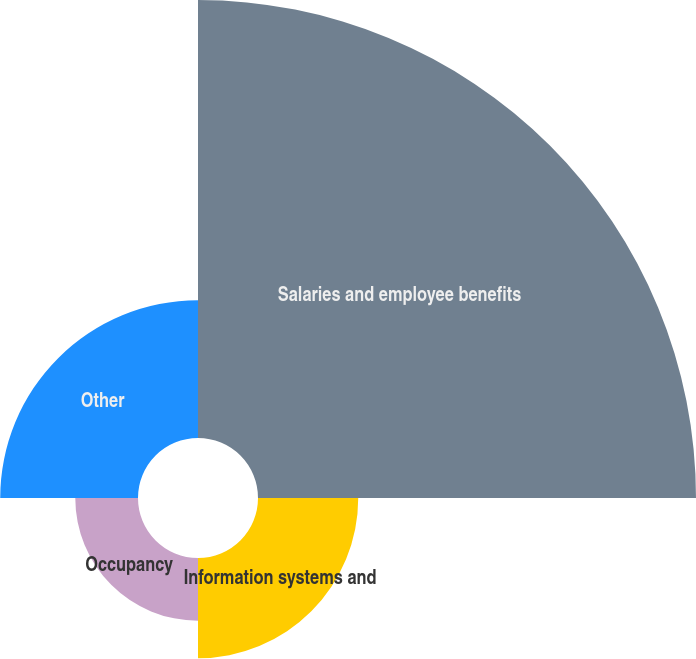Convert chart to OTSL. <chart><loc_0><loc_0><loc_500><loc_500><pie_chart><fcel>Salaries and employee benefits<fcel>Information systems and<fcel>Occupancy<fcel>Other<nl><fcel>59.29%<fcel>13.57%<fcel>8.49%<fcel>18.65%<nl></chart> 